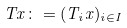Convert formula to latex. <formula><loc_0><loc_0><loc_500><loc_500>T x \colon = ( T _ { i } x ) _ { i \in I }</formula> 